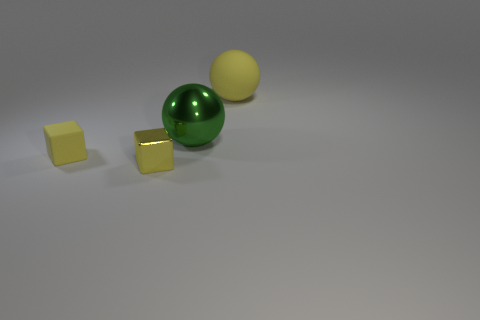Add 4 blue rubber blocks. How many objects exist? 8 Subtract 0 brown spheres. How many objects are left? 4 Subtract all big yellow balls. Subtract all tiny cubes. How many objects are left? 1 Add 1 tiny yellow matte things. How many tiny yellow matte things are left? 2 Add 4 green metal balls. How many green metal balls exist? 5 